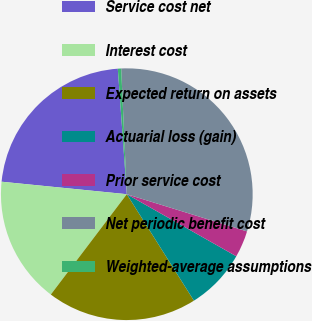Convert chart to OTSL. <chart><loc_0><loc_0><loc_500><loc_500><pie_chart><fcel>Service cost net<fcel>Interest cost<fcel>Expected return on assets<fcel>Actuarial loss (gain)<fcel>Prior service cost<fcel>Net periodic benefit cost<fcel>Weighted-average assumptions<nl><fcel>22.28%<fcel>16.27%<fcel>19.27%<fcel>7.84%<fcel>3.43%<fcel>30.49%<fcel>0.43%<nl></chart> 